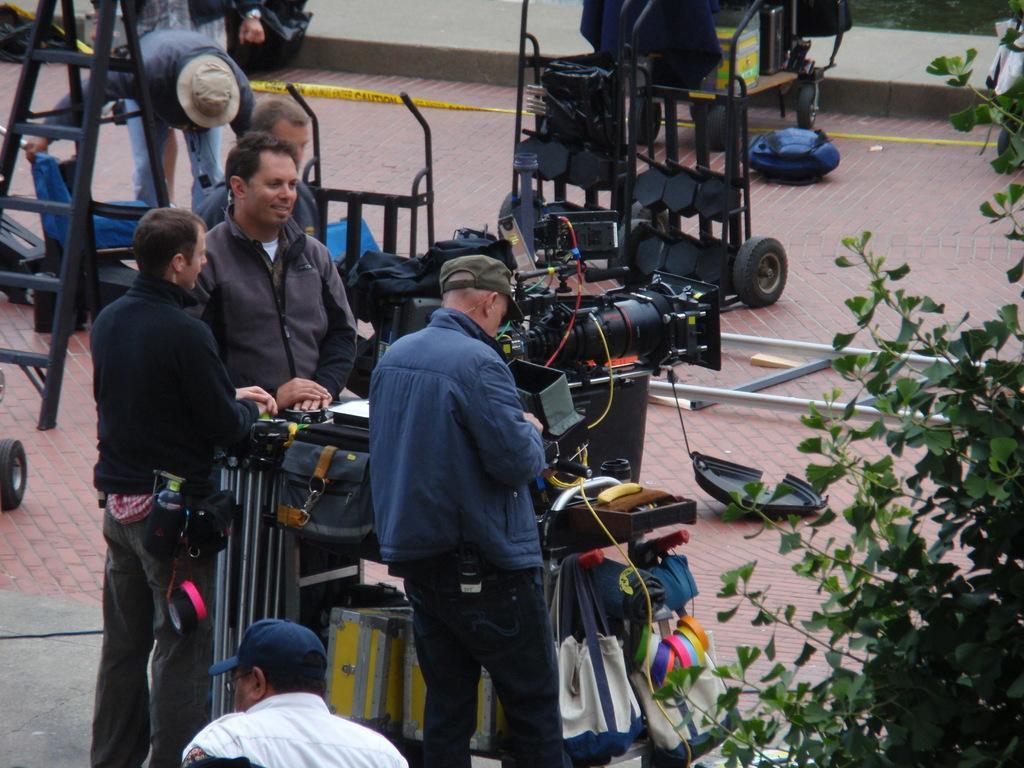How would you summarize this image in a sentence or two? In the center of the image there are people and we can see a camera placed on the stand. There are bags and we can see some equipment. On the left there is a ladder. On the right there is a tree. In the background there is a wall. 